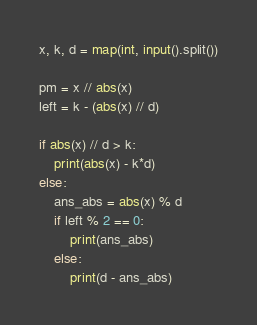Convert code to text. <code><loc_0><loc_0><loc_500><loc_500><_Python_>x, k, d = map(int, input().split())

pm = x // abs(x)
left = k - (abs(x) // d)

if abs(x) // d > k:
    print(abs(x) - k*d)
else:
    ans_abs = abs(x) % d
    if left % 2 == 0:
        print(ans_abs)
    else:
        print(d - ans_abs)
</code> 